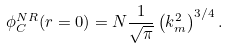Convert formula to latex. <formula><loc_0><loc_0><loc_500><loc_500>\phi _ { C } ^ { N R } ( r = 0 ) = N \frac { 1 } { \sqrt { \pi } } \left ( k _ { m } ^ { 2 } \right ) ^ { 3 / 4 } .</formula> 